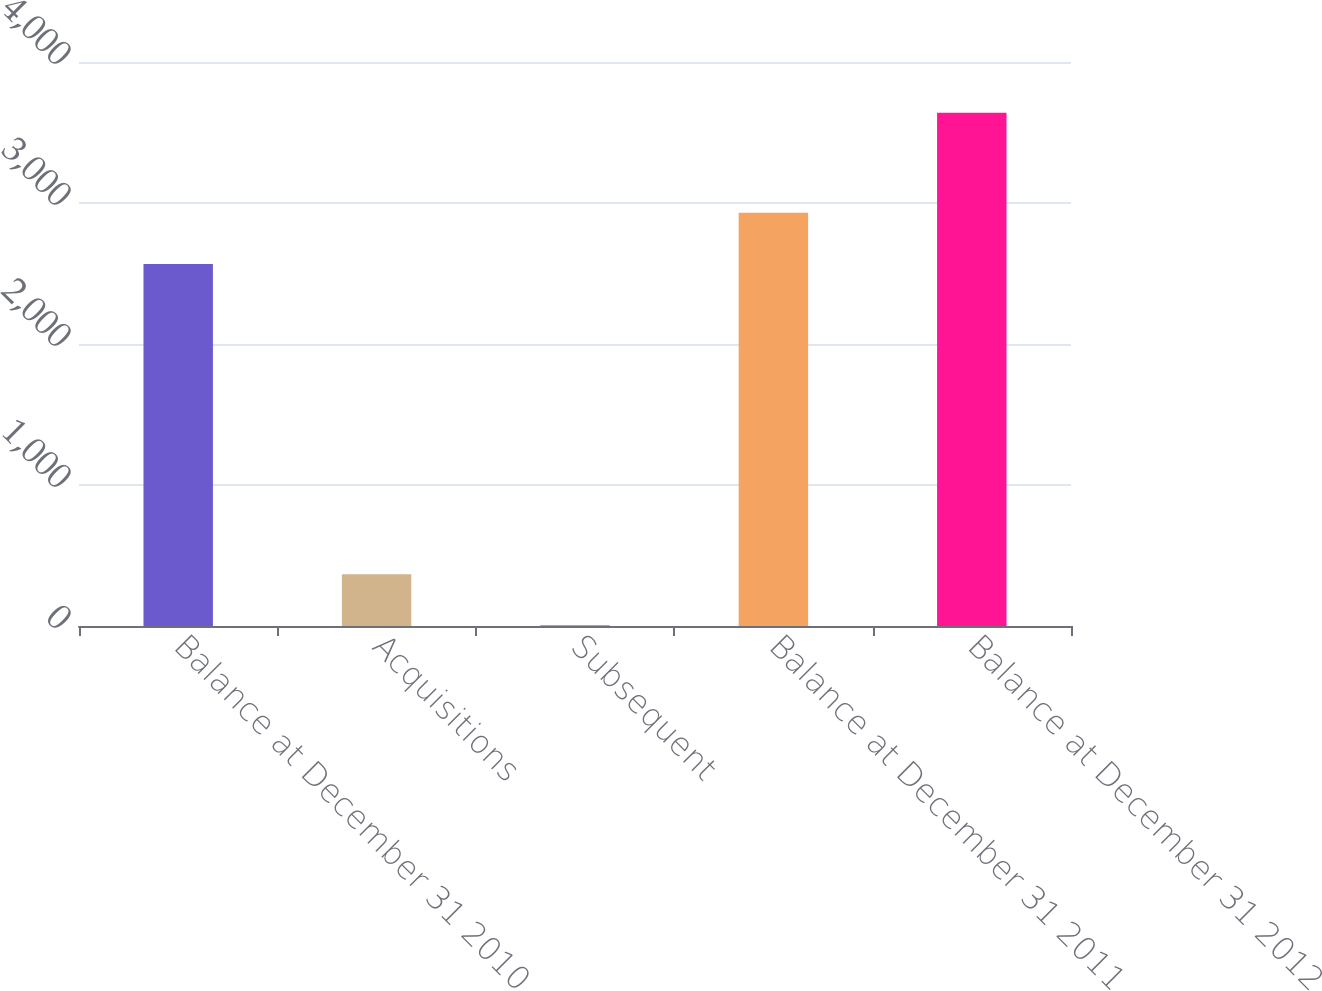<chart> <loc_0><loc_0><loc_500><loc_500><bar_chart><fcel>Balance at December 31 2010<fcel>Acquisitions<fcel>Subsequent<fcel>Balance at December 31 2011<fcel>Balance at December 31 2012<nl><fcel>2568<fcel>366.7<fcel>3<fcel>2931.7<fcel>3640<nl></chart> 